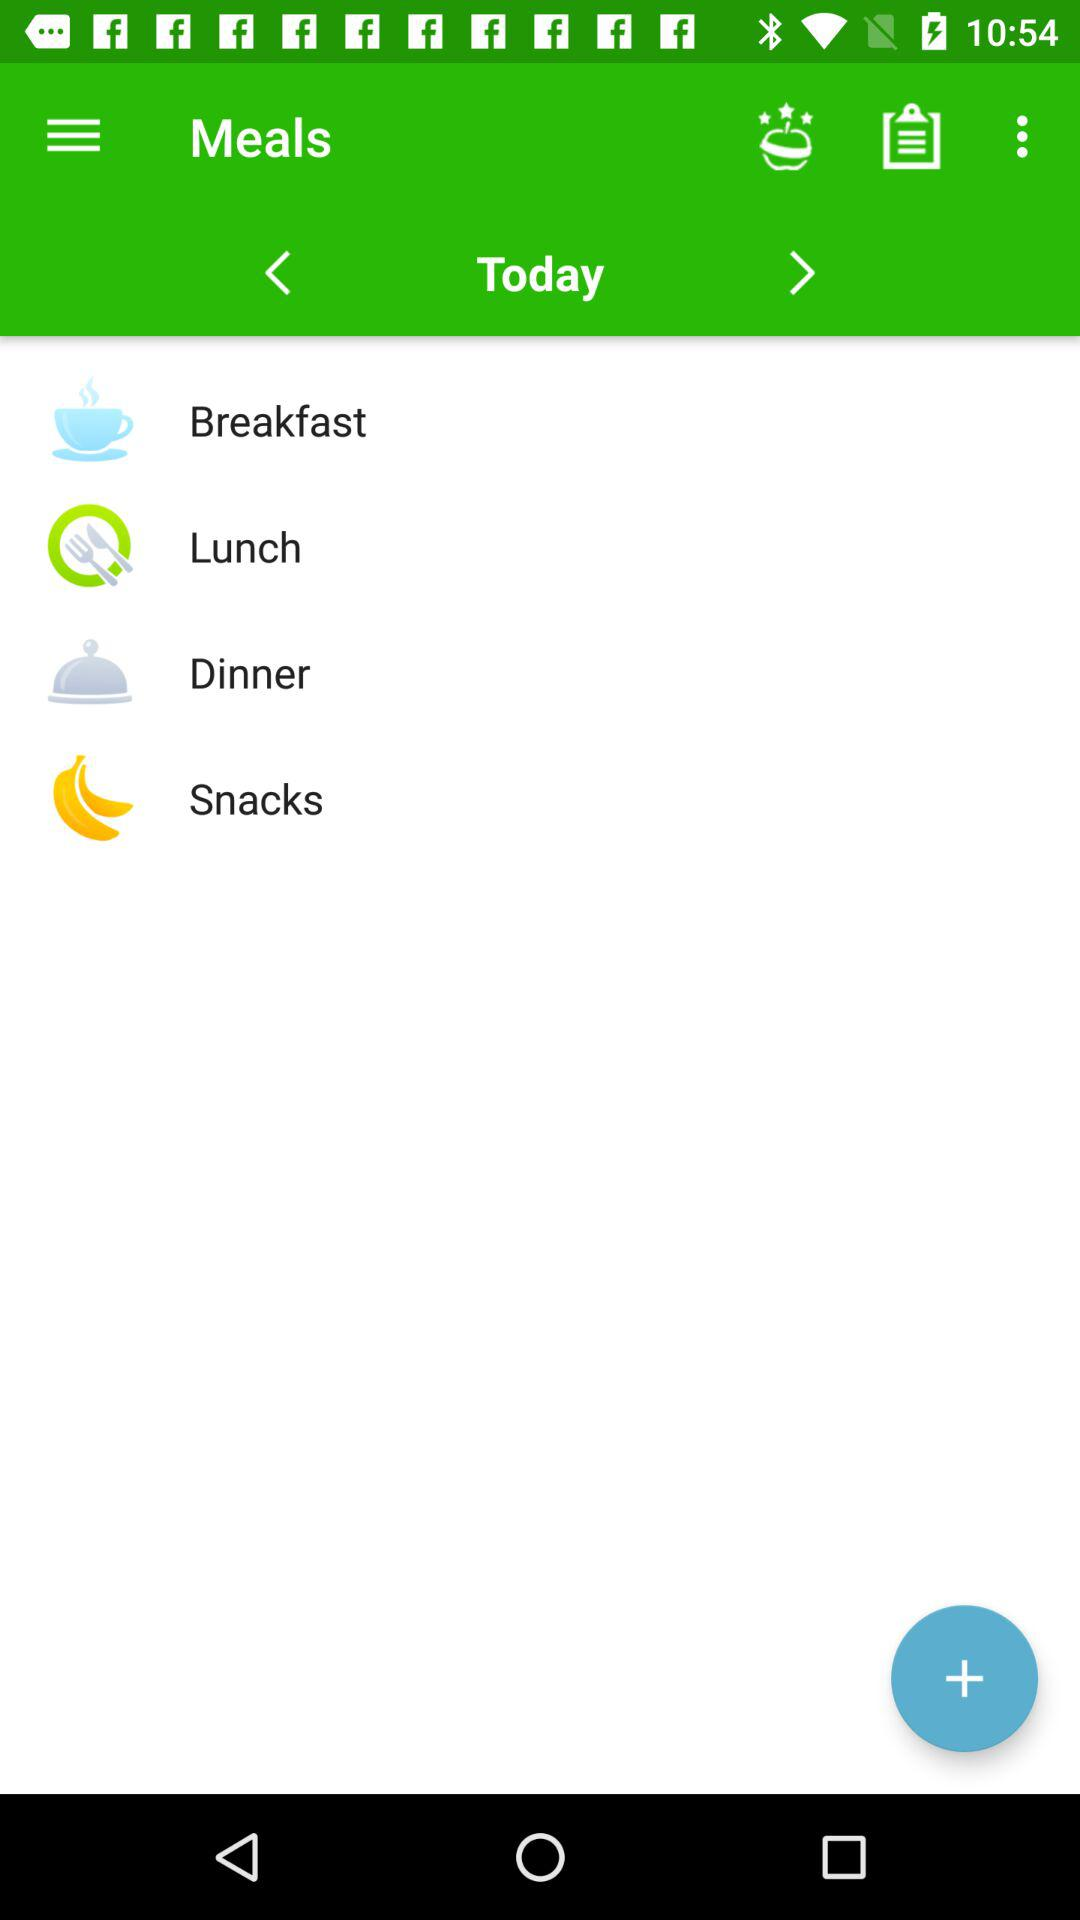How many meals are there in total?
Answer the question using a single word or phrase. 4 